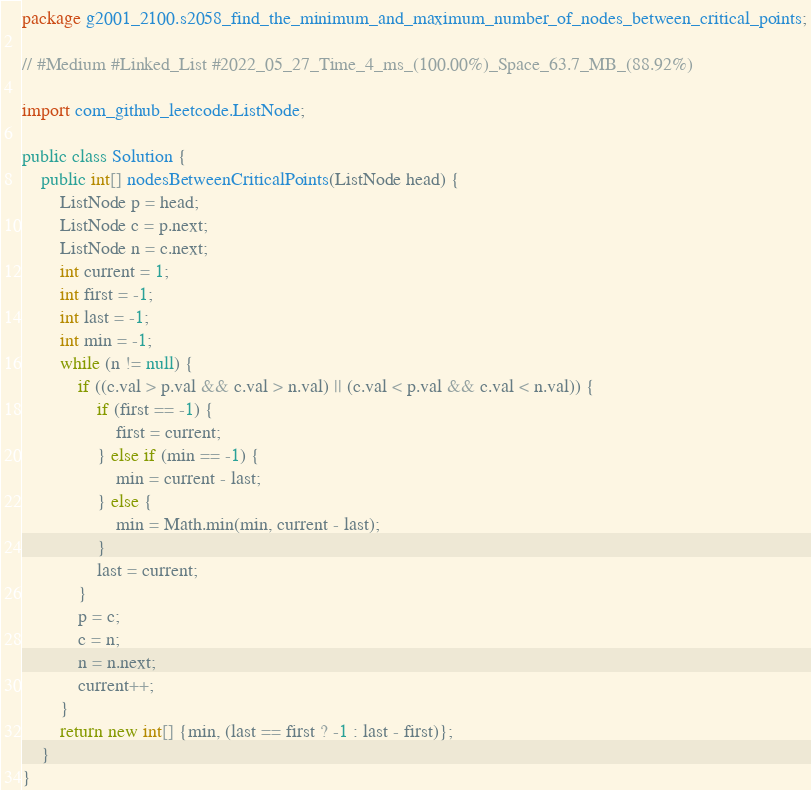<code> <loc_0><loc_0><loc_500><loc_500><_Java_>package g2001_2100.s2058_find_the_minimum_and_maximum_number_of_nodes_between_critical_points;

// #Medium #Linked_List #2022_05_27_Time_4_ms_(100.00%)_Space_63.7_MB_(88.92%)

import com_github_leetcode.ListNode;

public class Solution {
    public int[] nodesBetweenCriticalPoints(ListNode head) {
        ListNode p = head;
        ListNode c = p.next;
        ListNode n = c.next;
        int current = 1;
        int first = -1;
        int last = -1;
        int min = -1;
        while (n != null) {
            if ((c.val > p.val && c.val > n.val) || (c.val < p.val && c.val < n.val)) {
                if (first == -1) {
                    first = current;
                } else if (min == -1) {
                    min = current - last;
                } else {
                    min = Math.min(min, current - last);
                }
                last = current;
            }
            p = c;
            c = n;
            n = n.next;
            current++;
        }
        return new int[] {min, (last == first ? -1 : last - first)};
    }
}
</code> 